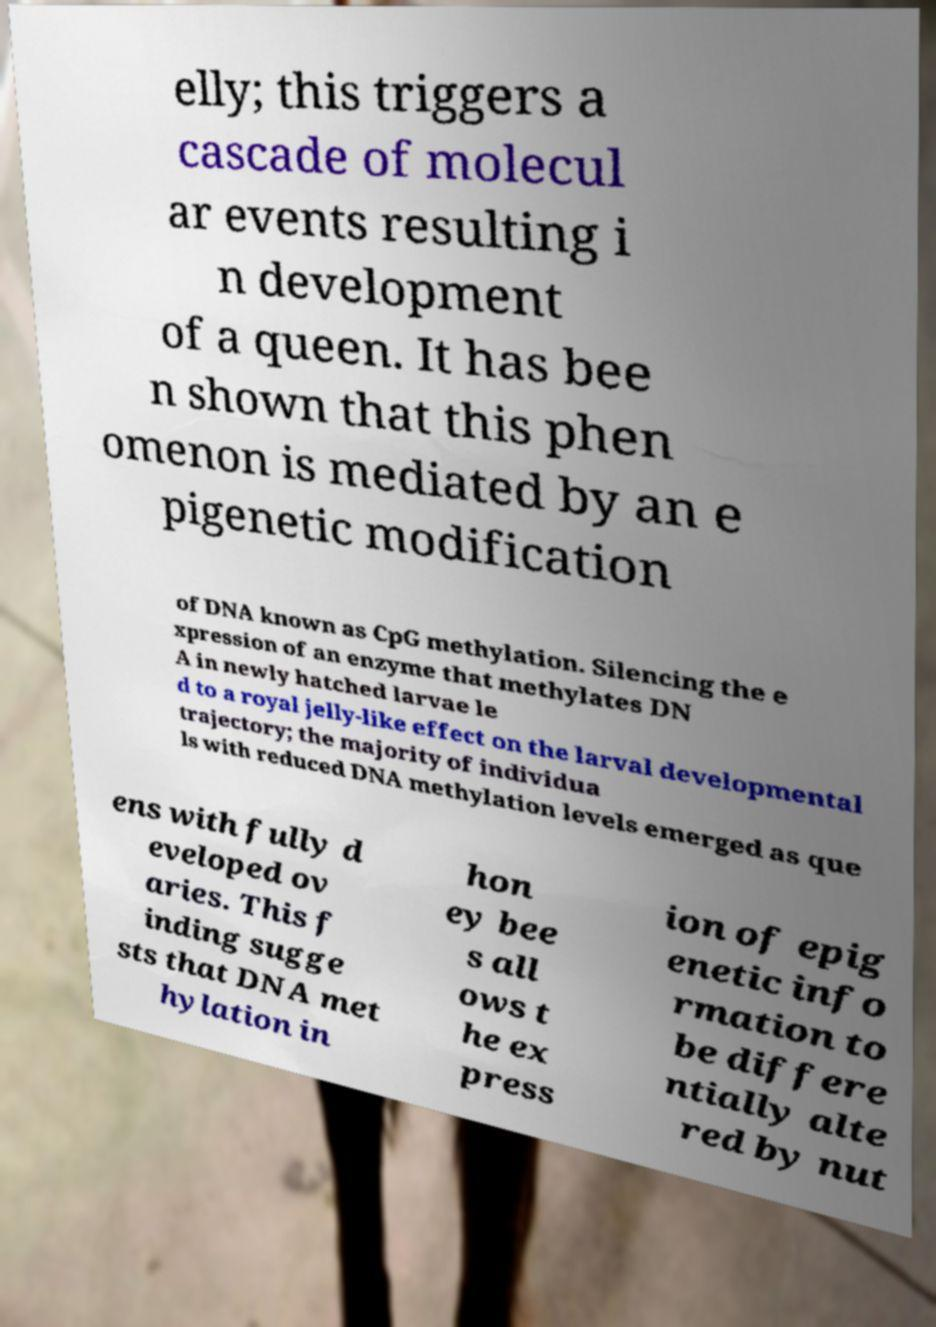For documentation purposes, I need the text within this image transcribed. Could you provide that? elly; this triggers a cascade of molecul ar events resulting i n development of a queen. It has bee n shown that this phen omenon is mediated by an e pigenetic modification of DNA known as CpG methylation. Silencing the e xpression of an enzyme that methylates DN A in newly hatched larvae le d to a royal jelly-like effect on the larval developmental trajectory; the majority of individua ls with reduced DNA methylation levels emerged as que ens with fully d eveloped ov aries. This f inding sugge sts that DNA met hylation in hon ey bee s all ows t he ex press ion of epig enetic info rmation to be differe ntially alte red by nut 